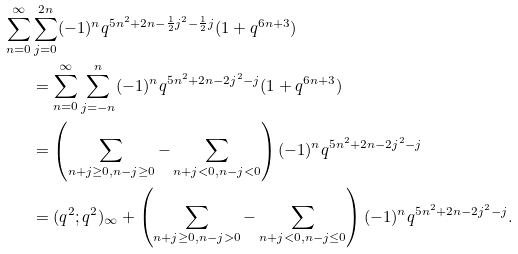Convert formula to latex. <formula><loc_0><loc_0><loc_500><loc_500>\sum _ { n = 0 } ^ { \infty } & \sum _ { j = 0 } ^ { 2 n } ( - 1 ) ^ { n } q ^ { 5 n ^ { 2 } + 2 n - \frac { 1 } { 2 } j ^ { 2 } - \frac { 1 } { 2 } j } ( 1 + q ^ { 6 n + 3 } ) \\ & = \sum _ { n = 0 } ^ { \infty } \sum _ { j = - n } ^ { n } ( - 1 ) ^ { n } q ^ { 5 n ^ { 2 } + 2 n - 2 j ^ { 2 } - j } ( 1 + q ^ { 6 n + 3 } ) \\ & = \left ( \sum _ { n + j \geq 0 , n - j \geq 0 } - \sum _ { n + j < 0 , n - j < 0 } \right ) ( - 1 ) ^ { n } q ^ { 5 n ^ { 2 } + 2 n - 2 j ^ { 2 } - j } \\ & = ( q ^ { 2 } ; q ^ { 2 } ) _ { \infty } + \left ( \sum _ { n + j \geq 0 , n - j > 0 } - \sum _ { n + j < 0 , n - j \leq 0 } \right ) ( - 1 ) ^ { n } q ^ { 5 n ^ { 2 } + 2 n - 2 j ^ { 2 } - j } .</formula> 